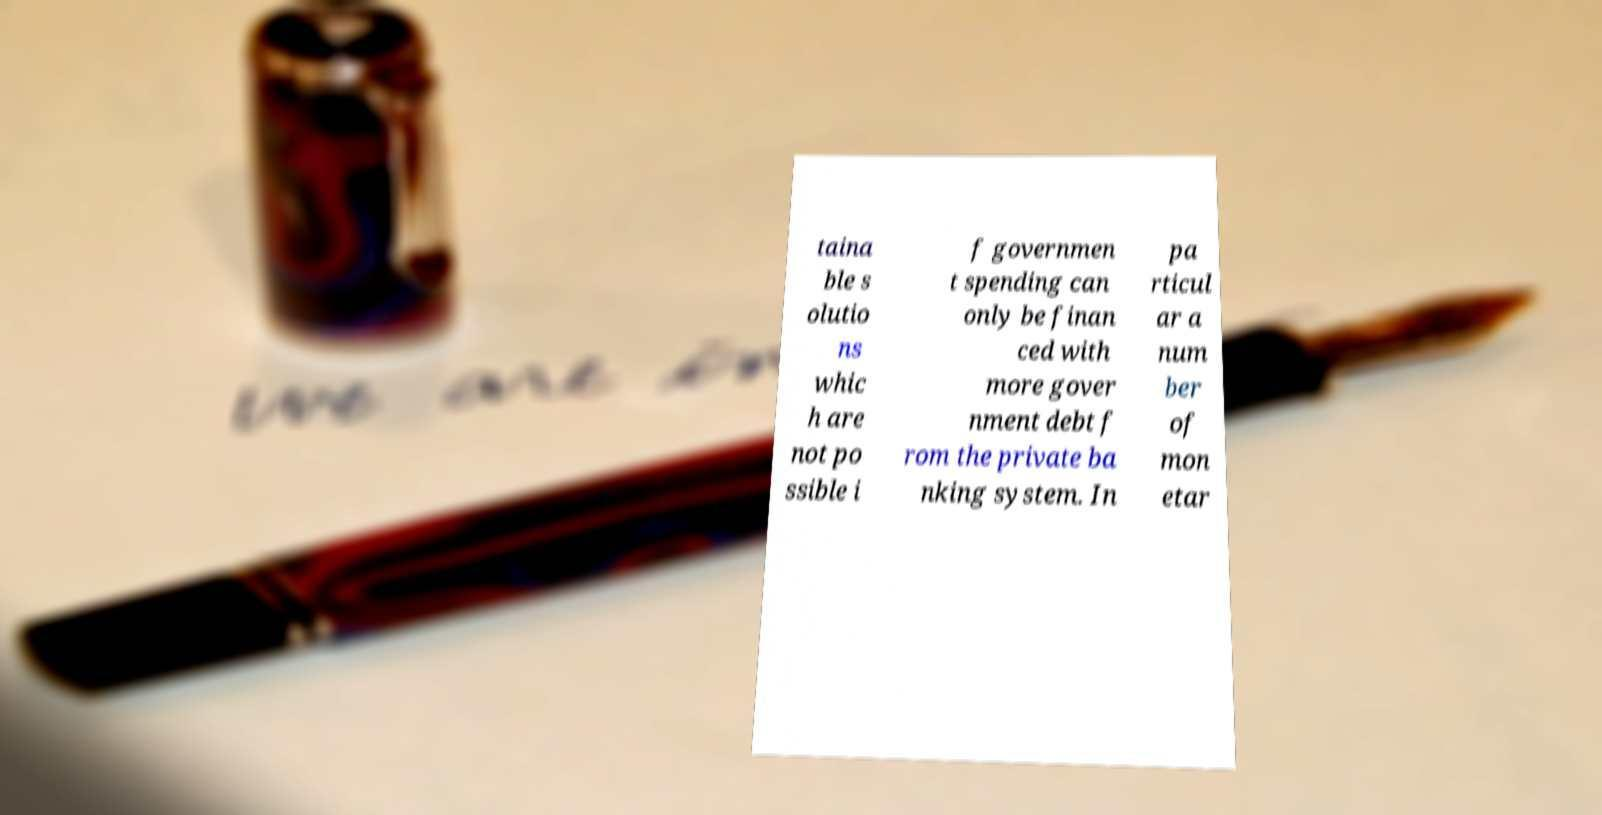Could you assist in decoding the text presented in this image and type it out clearly? taina ble s olutio ns whic h are not po ssible i f governmen t spending can only be finan ced with more gover nment debt f rom the private ba nking system. In pa rticul ar a num ber of mon etar 